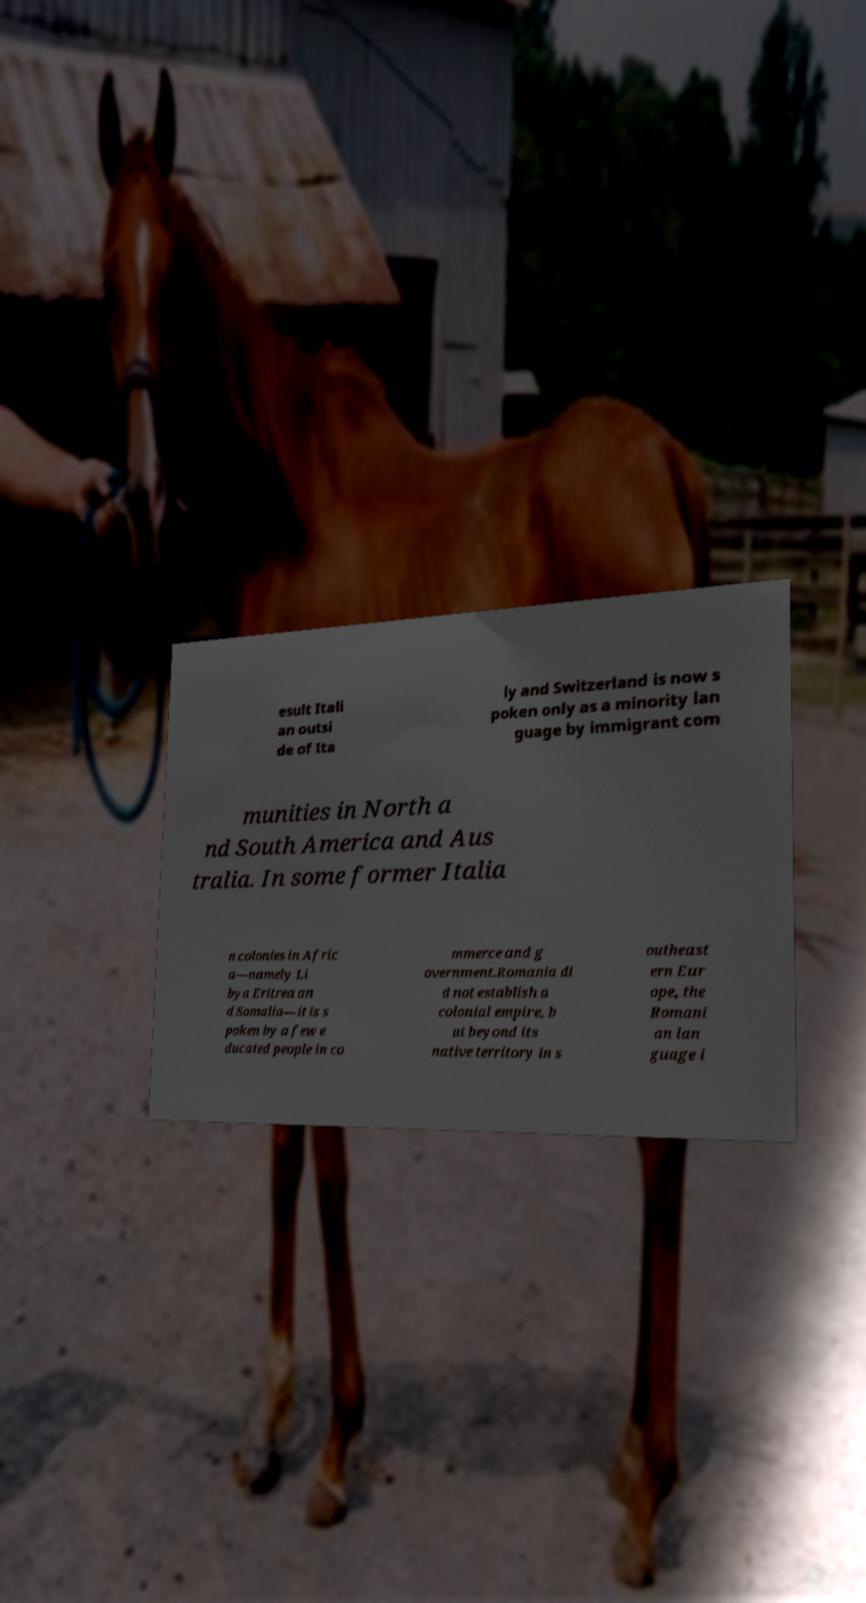Can you accurately transcribe the text from the provided image for me? esult Itali an outsi de of Ita ly and Switzerland is now s poken only as a minority lan guage by immigrant com munities in North a nd South America and Aus tralia. In some former Italia n colonies in Afric a—namely Li bya Eritrea an d Somalia—it is s poken by a few e ducated people in co mmerce and g overnment.Romania di d not establish a colonial empire, b ut beyond its native territory in s outheast ern Eur ope, the Romani an lan guage i 